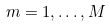<formula> <loc_0><loc_0><loc_500><loc_500>m = 1 , \dots , M</formula> 